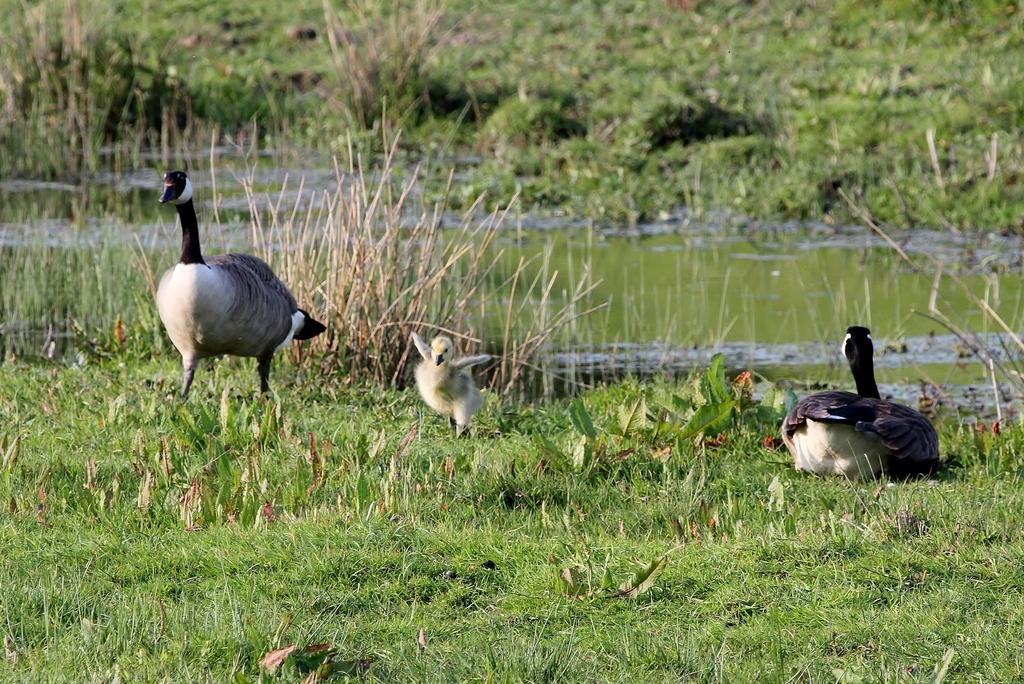What type of animals can be seen in the image? There are birds in the image. What is the primary element in which the birds are situated? The birds are situated in water. What type of terrain is visible in the image? There is grassy land in the image. What other living organisms can be seen in the image? There are plants in the image. What type of fuel is being used by the birds in the image? There is no fuel present in the image, as birds do not use fuel for their activities. 